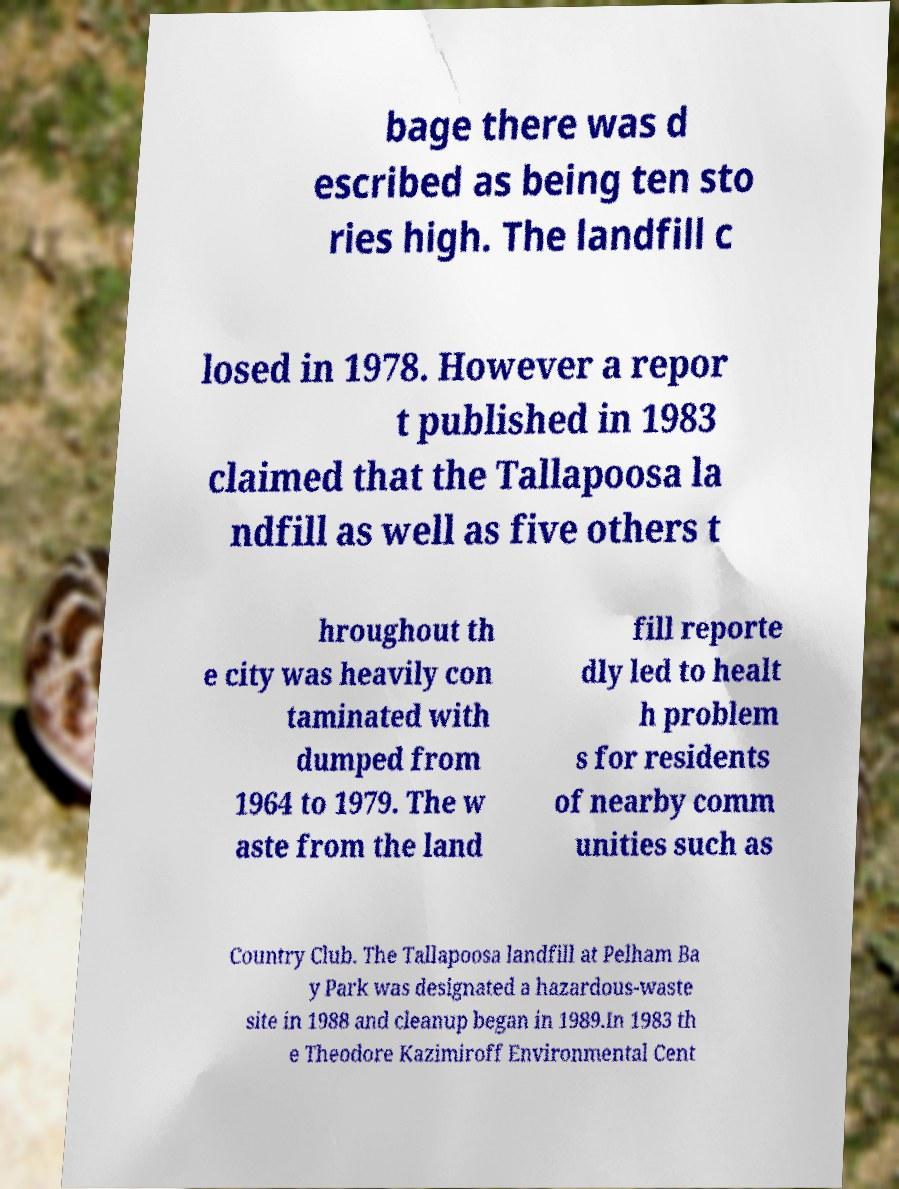For documentation purposes, I need the text within this image transcribed. Could you provide that? bage there was d escribed as being ten sto ries high. The landfill c losed in 1978. However a repor t published in 1983 claimed that the Tallapoosa la ndfill as well as five others t hroughout th e city was heavily con taminated with dumped from 1964 to 1979. The w aste from the land fill reporte dly led to healt h problem s for residents of nearby comm unities such as Country Club. The Tallapoosa landfill at Pelham Ba y Park was designated a hazardous-waste site in 1988 and cleanup began in 1989.In 1983 th e Theodore Kazimiroff Environmental Cent 